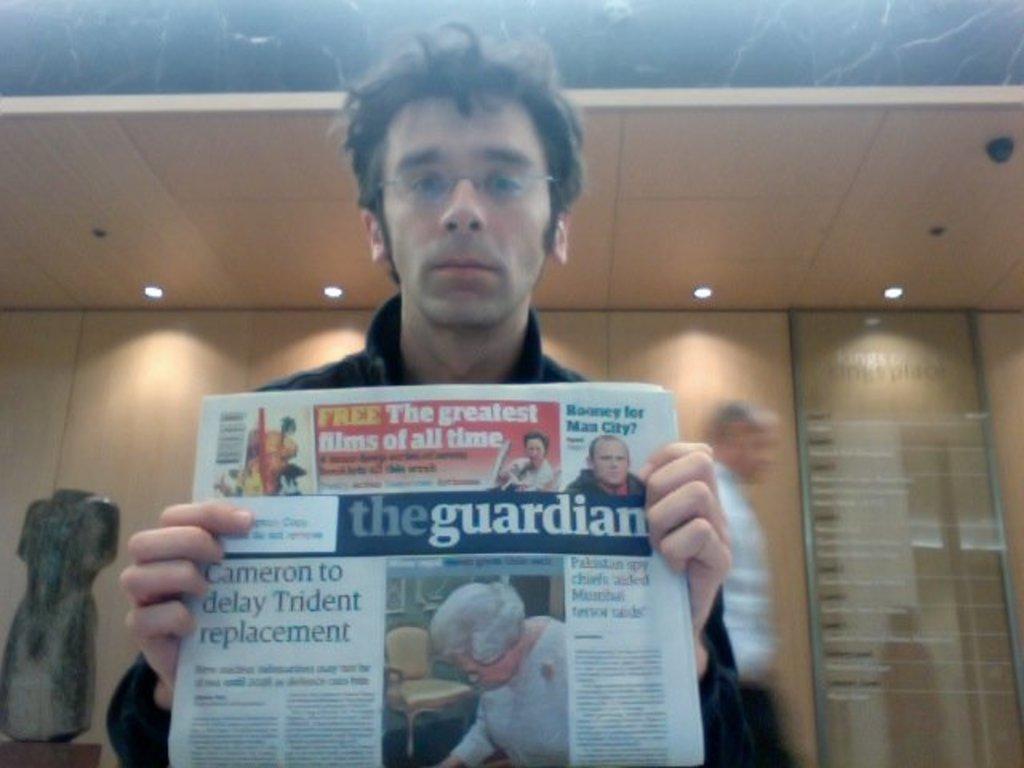Describe this image in one or two sentences. In this picture I can see a man standing and holding a newspaper in his hands and another man moving on the back and I can see a board with some text on the wall and a mannequin on the left side of the picture on the table and few lights to the ceiling and a man wore spectacles on his face. 